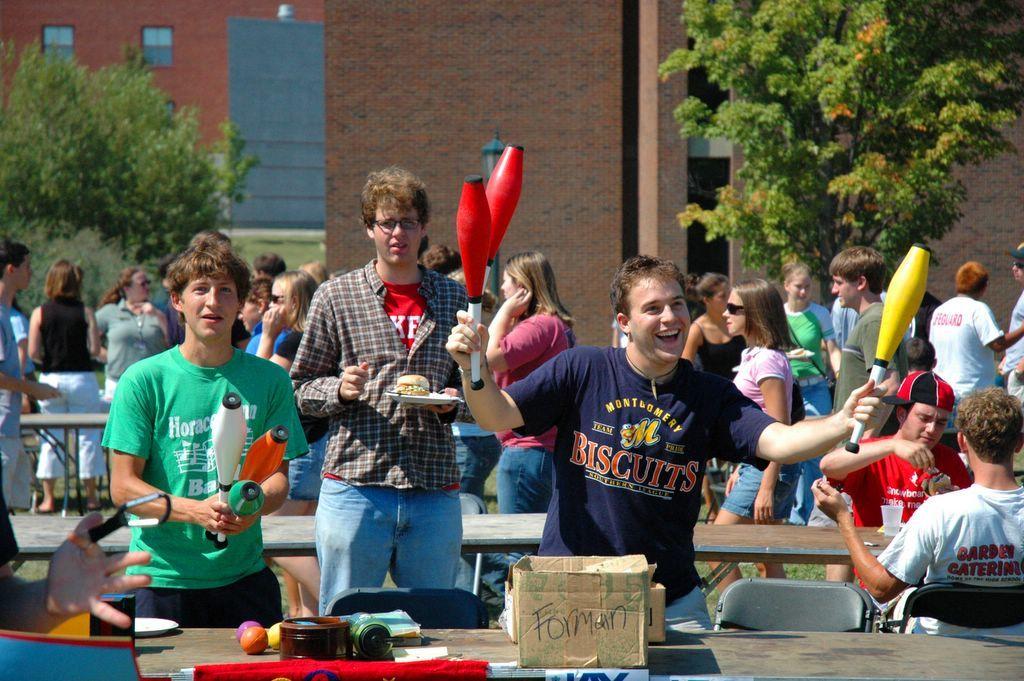What does it say on the box in front of the juggler?
Offer a very short reply. Forman. 